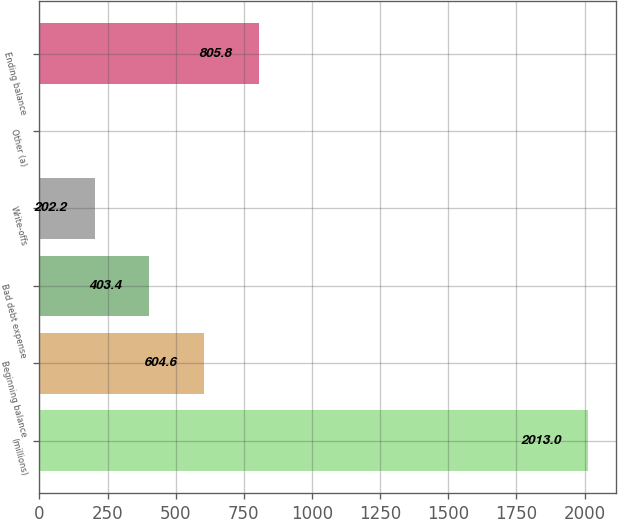<chart> <loc_0><loc_0><loc_500><loc_500><bar_chart><fcel>(millions)<fcel>Beginning balance<fcel>Bad debt expense<fcel>Write-offs<fcel>Other (a)<fcel>Ending balance<nl><fcel>2013<fcel>604.6<fcel>403.4<fcel>202.2<fcel>1<fcel>805.8<nl></chart> 